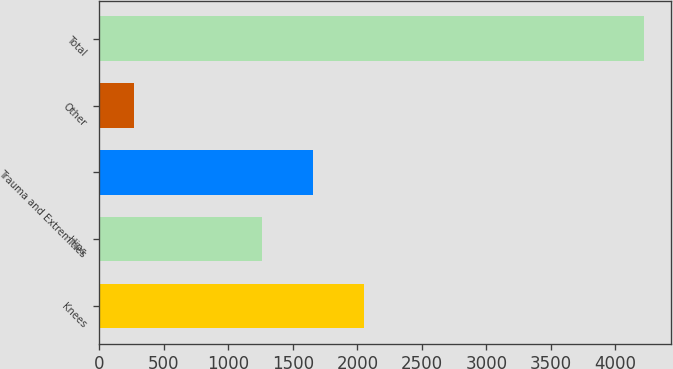<chart> <loc_0><loc_0><loc_500><loc_500><bar_chart><fcel>Knees<fcel>Hips<fcel>Trauma and Extremities<fcel>Other<fcel>Total<nl><fcel>2054.4<fcel>1263<fcel>1658.7<fcel>266<fcel>4223<nl></chart> 